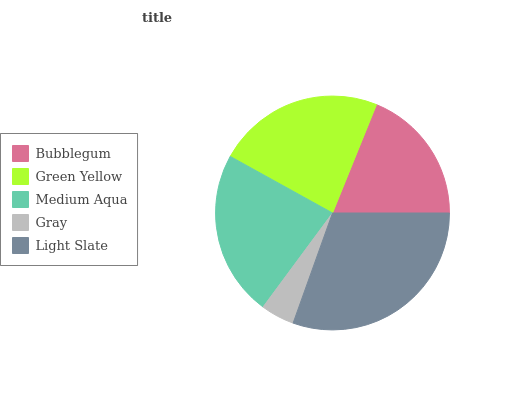Is Gray the minimum?
Answer yes or no. Yes. Is Light Slate the maximum?
Answer yes or no. Yes. Is Green Yellow the minimum?
Answer yes or no. No. Is Green Yellow the maximum?
Answer yes or no. No. Is Green Yellow greater than Bubblegum?
Answer yes or no. Yes. Is Bubblegum less than Green Yellow?
Answer yes or no. Yes. Is Bubblegum greater than Green Yellow?
Answer yes or no. No. Is Green Yellow less than Bubblegum?
Answer yes or no. No. Is Medium Aqua the high median?
Answer yes or no. Yes. Is Medium Aqua the low median?
Answer yes or no. Yes. Is Green Yellow the high median?
Answer yes or no. No. Is Green Yellow the low median?
Answer yes or no. No. 